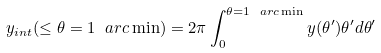Convert formula to latex. <formula><loc_0><loc_0><loc_500><loc_500>y _ { i n t } ( \leq \theta = 1 \ a r c \min ) = 2 \pi \int _ { 0 } ^ { \theta = 1 \ a r c \min } y ( \theta ^ { \prime } ) \theta ^ { \prime } d \theta ^ { \prime }</formula> 